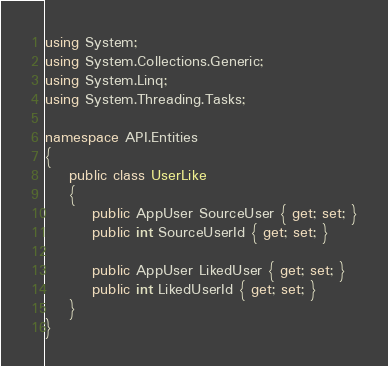Convert code to text. <code><loc_0><loc_0><loc_500><loc_500><_C#_>using System;
using System.Collections.Generic;
using System.Linq;
using System.Threading.Tasks;

namespace API.Entities
{
    public class UserLike
    {
        public AppUser SourceUser { get; set; }
        public int SourceUserId { get; set; }

        public AppUser LikedUser { get; set; }
        public int LikedUserId { get; set; }
    }
}</code> 